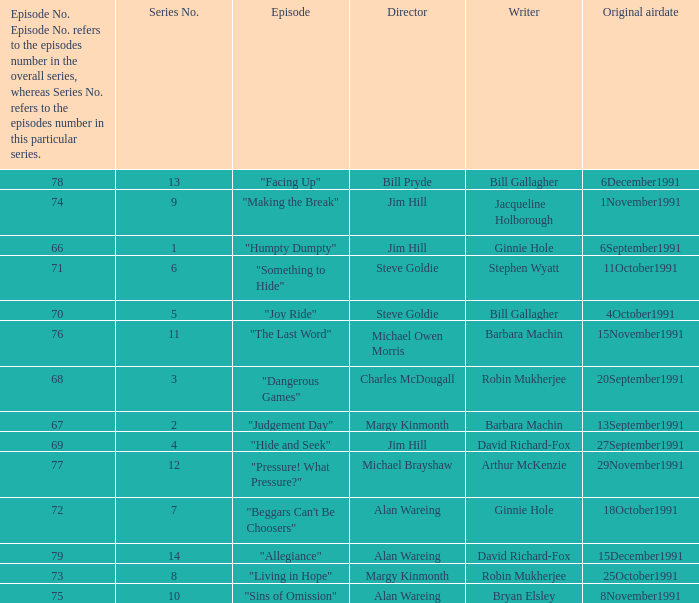Name the original airdate for robin mukherjee and margy kinmonth 25October1991. 